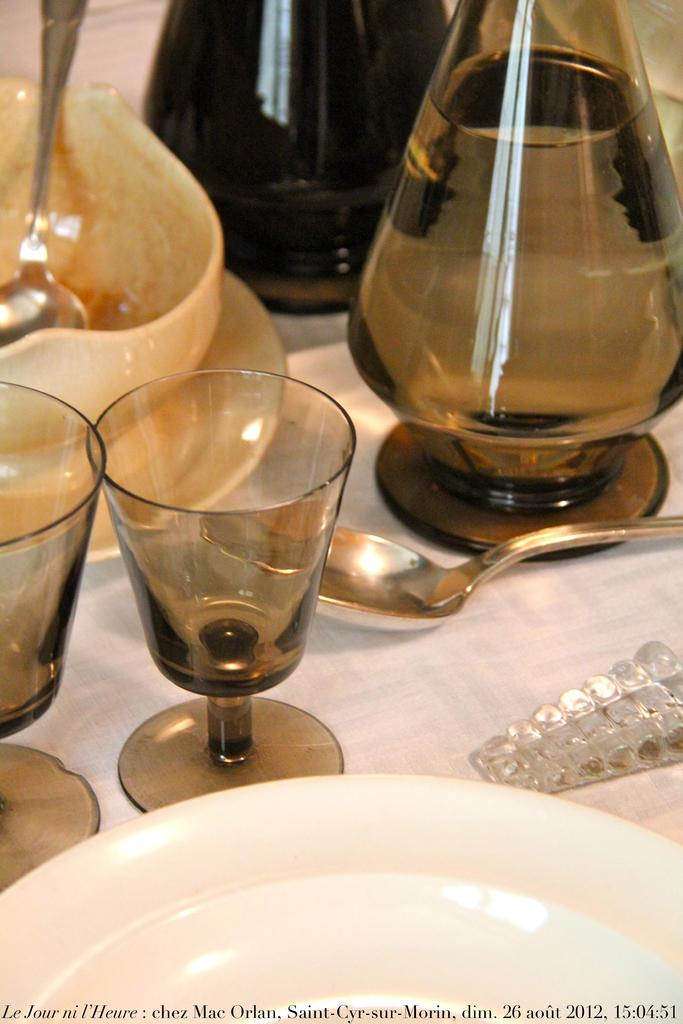What type of tableware can be seen in the image? There are plates, glasses, and spoons in the image. What else is present in the image besides tableware? There is a bowl and jars with water in the image. Can you describe the object on the table in the image? There is an object on the table in the image, but its specific nature is not clear from the provided facts. What is written at the bottom of the image? There is some text at the bottom of the image. What action is the team performing in the image? There is no team or action present in the image; it only contains tableware, a bowl, jars with water, an object on the table, and text at the bottom. How does the image show the process of burning? The image does not depict any burning or related processes; it is focused on tableware and related objects. 